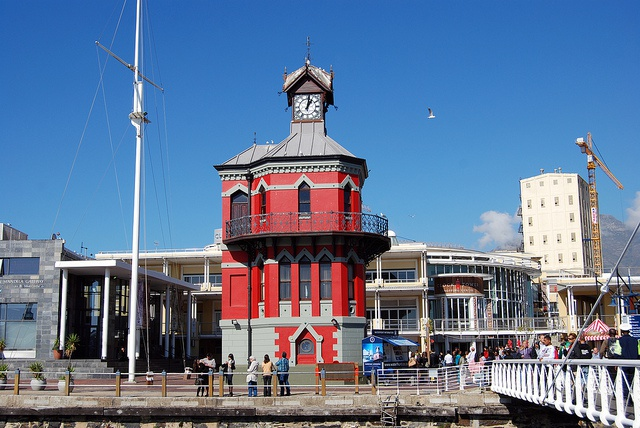Describe the objects in this image and their specific colors. I can see people in blue, black, gray, lightgray, and darkgray tones, clock in blue, white, darkgray, gray, and black tones, potted plant in blue, black, gray, darkgreen, and darkgray tones, people in blue, black, navy, gray, and darkgray tones, and people in blue, black, tan, and darkgray tones in this image. 